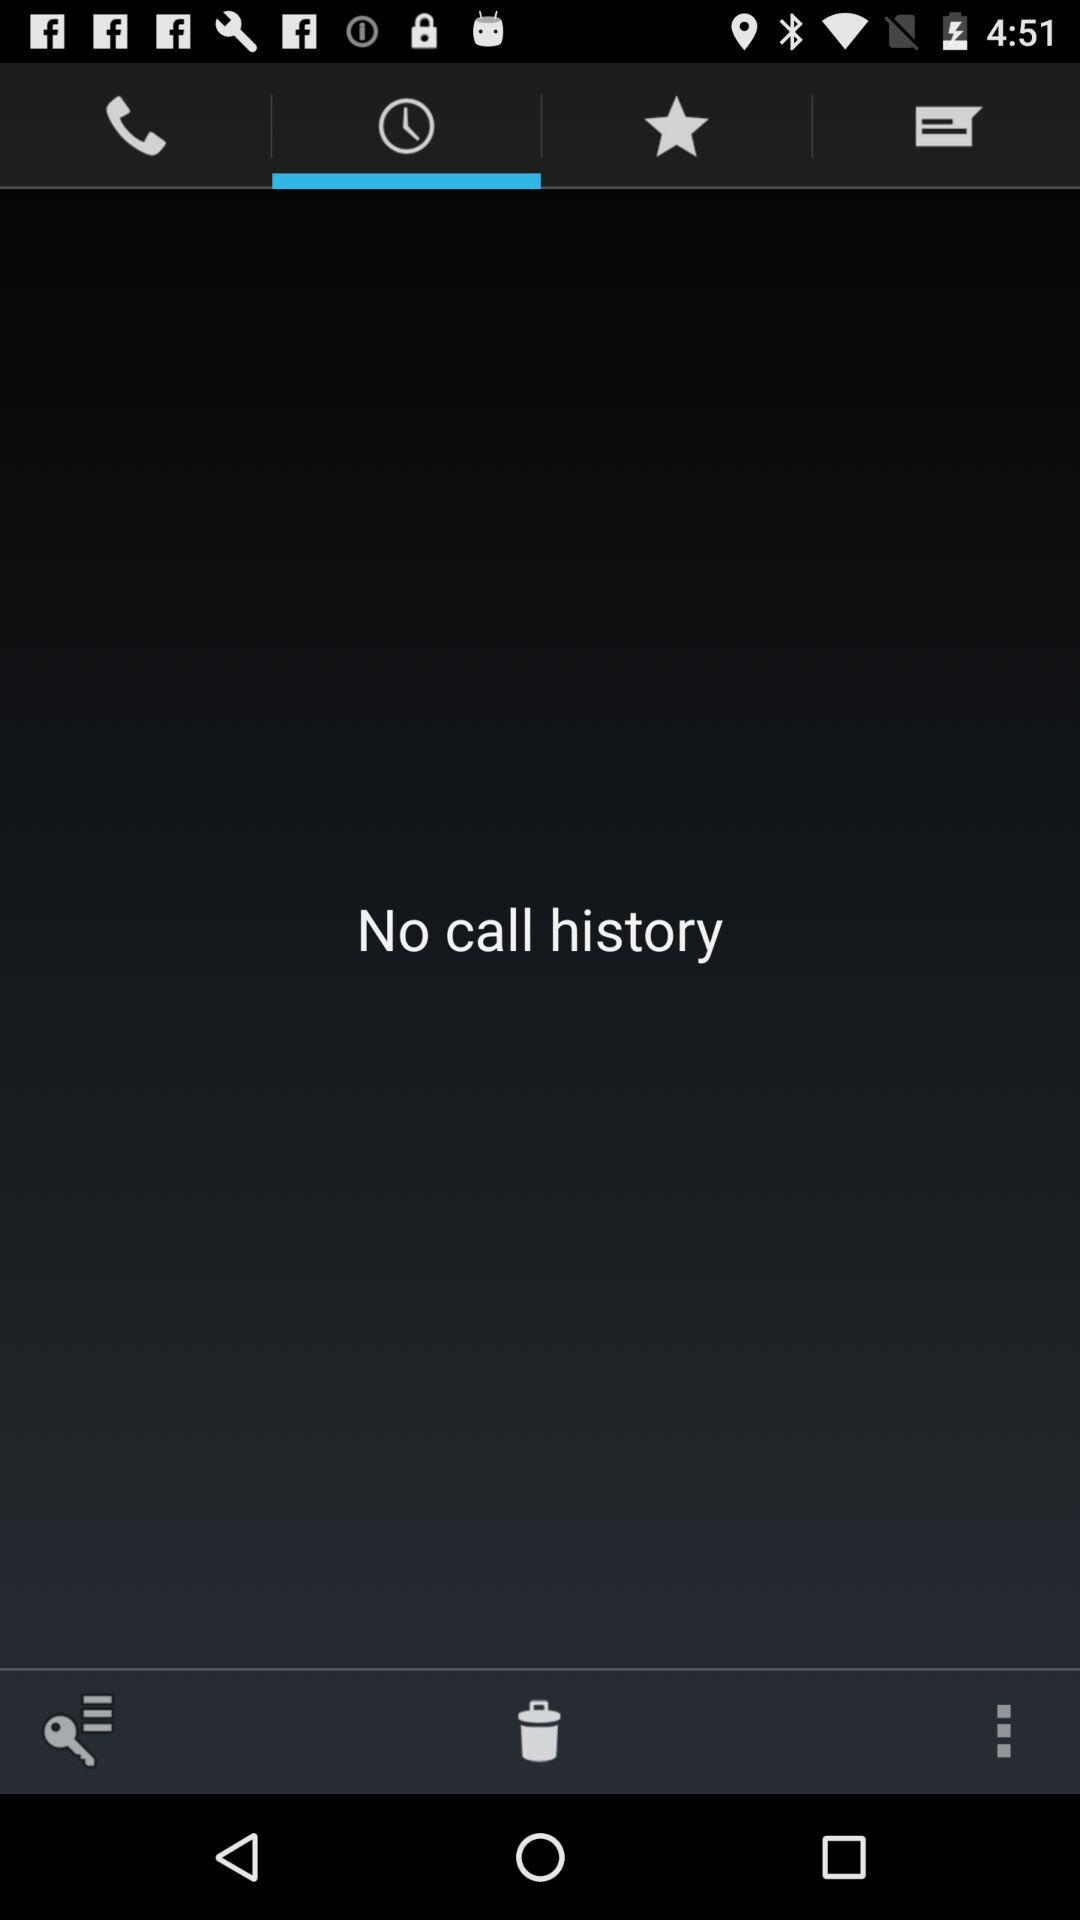Is there any call history? There is no call history. 